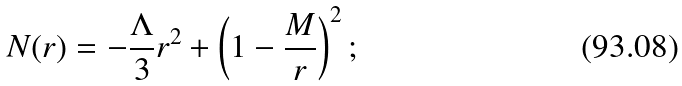Convert formula to latex. <formula><loc_0><loc_0><loc_500><loc_500>N ( r ) = - \frac { \Lambda } { 3 } r ^ { 2 } + \left ( 1 - \frac { M } { r } \right ) ^ { 2 } ;</formula> 